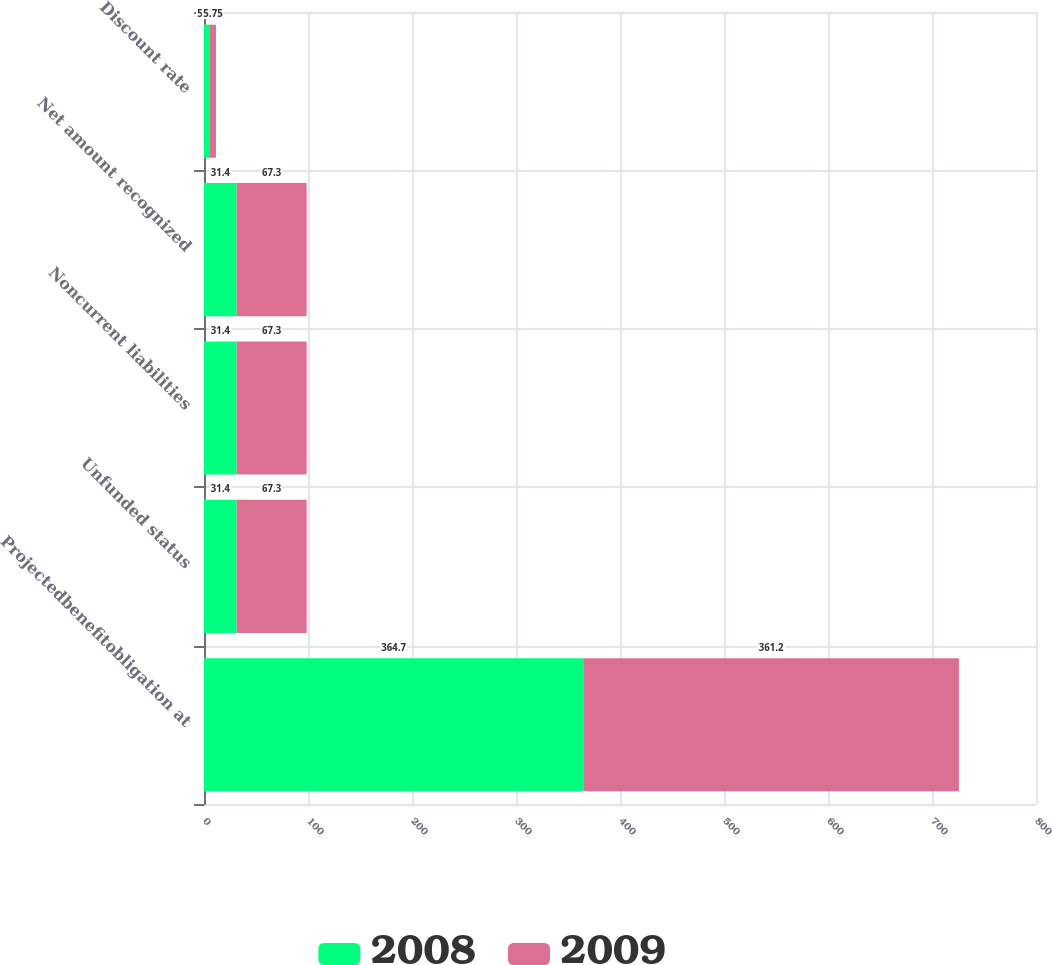Convert chart to OTSL. <chart><loc_0><loc_0><loc_500><loc_500><stacked_bar_chart><ecel><fcel>Projectedbenefitobligation at<fcel>Unfunded status<fcel>Noncurrent liabilities<fcel>Net amount recognized<fcel>Discount rate<nl><fcel>2008<fcel>364.7<fcel>31.4<fcel>31.4<fcel>31.4<fcel>5.75<nl><fcel>2009<fcel>361.2<fcel>67.3<fcel>67.3<fcel>67.3<fcel>5.75<nl></chart> 